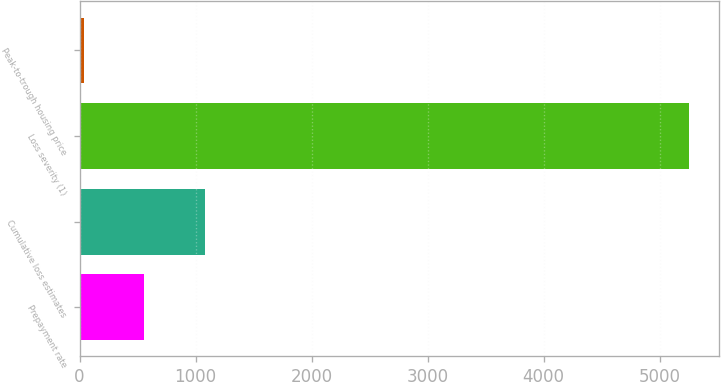Convert chart. <chart><loc_0><loc_0><loc_500><loc_500><bar_chart><fcel>Prepayment rate<fcel>Cumulative loss estimates<fcel>Loss severity (1)<fcel>Peak-to-trough housing price<nl><fcel>556.8<fcel>1078.6<fcel>5253<fcel>35<nl></chart> 